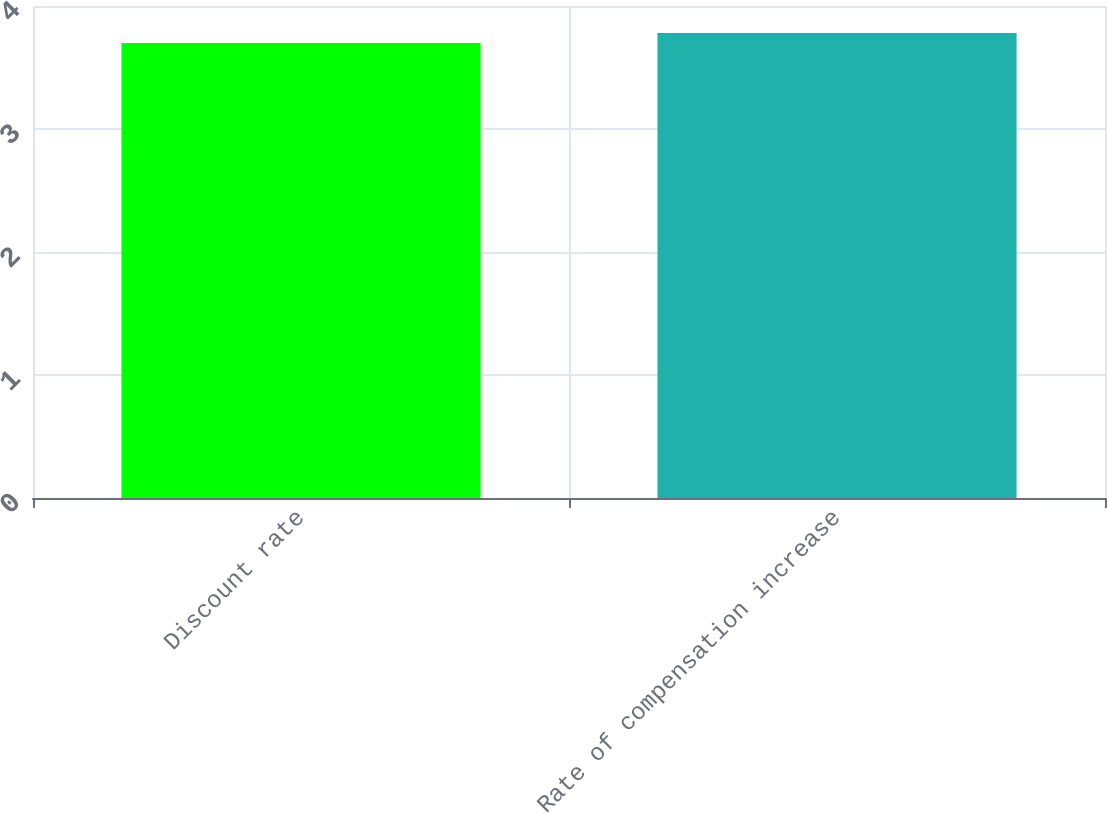<chart> <loc_0><loc_0><loc_500><loc_500><bar_chart><fcel>Discount rate<fcel>Rate of compensation increase<nl><fcel>3.7<fcel>3.78<nl></chart> 